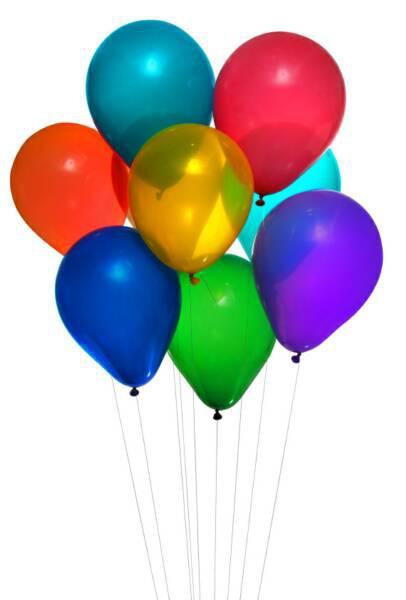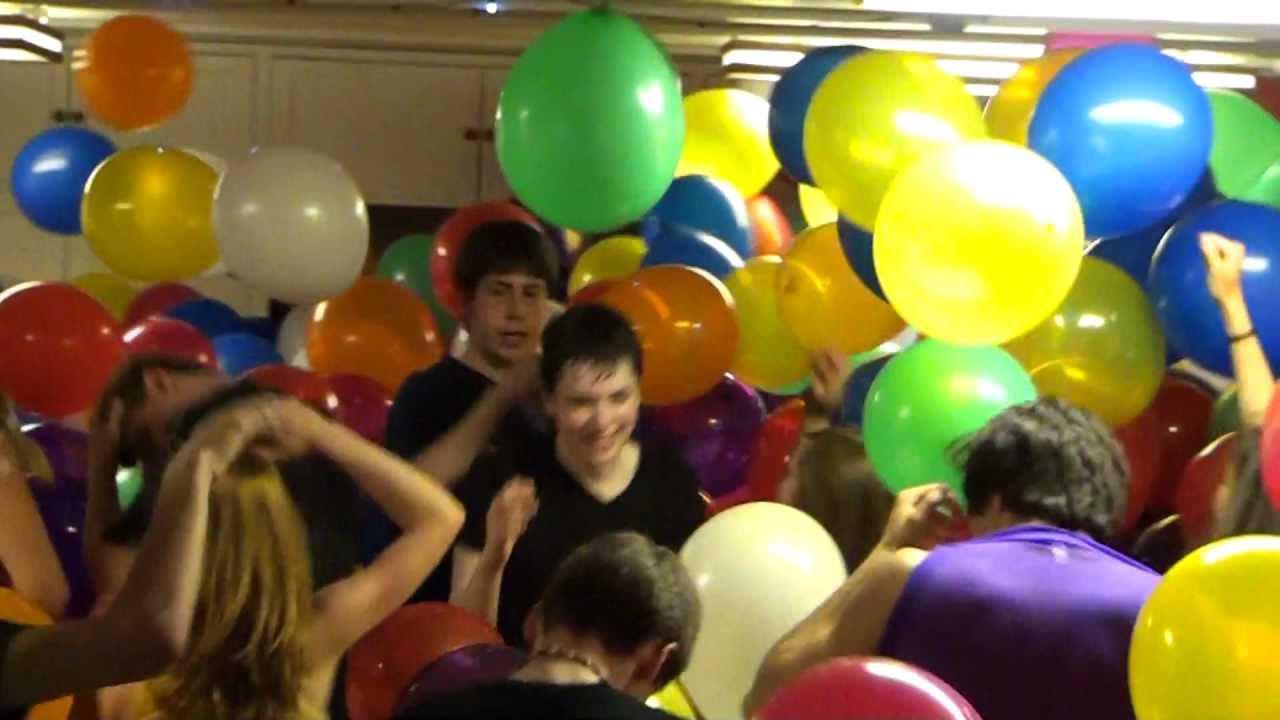The first image is the image on the left, the second image is the image on the right. Analyze the images presented: Is the assertion "Each image shows one bunch of different colored balloons with strings hanging down, and no bunch contains more than 10 balloons." valid? Answer yes or no. No. The first image is the image on the left, the second image is the image on the right. For the images displayed, is the sentence "In at least one image there are six different colored balloons." factually correct? Answer yes or no. No. 